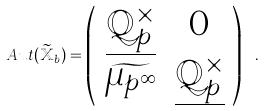Convert formula to latex. <formula><loc_0><loc_0><loc_500><loc_500>A u t ( \widetilde { \mathbb { X } } _ { b } ) = \left ( \begin{array} { c c } \underline { \mathbb { Q } _ { p } ^ { \times } } & 0 \\ \widetilde { \mu _ { p ^ { \infty } } } & \underline { \mathbb { Q } _ { p } ^ { \times } } \end{array} \right ) \ .</formula> 